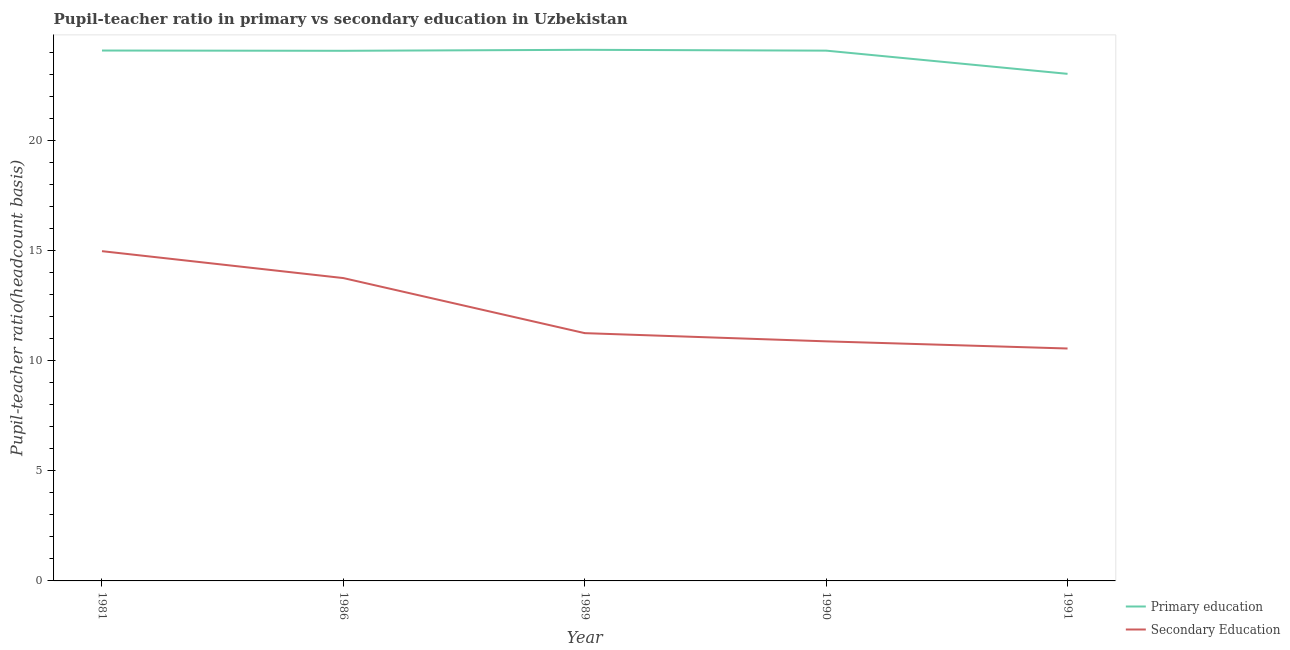How many different coloured lines are there?
Offer a very short reply. 2. What is the pupil teacher ratio on secondary education in 1991?
Provide a short and direct response. 10.56. Across all years, what is the maximum pupil teacher ratio on secondary education?
Offer a terse response. 14.99. Across all years, what is the minimum pupil-teacher ratio in primary education?
Give a very brief answer. 23.05. In which year was the pupil teacher ratio on secondary education minimum?
Provide a succinct answer. 1991. What is the total pupil teacher ratio on secondary education in the graph?
Give a very brief answer. 61.47. What is the difference between the pupil-teacher ratio in primary education in 1981 and that in 1986?
Give a very brief answer. 0.01. What is the difference between the pupil teacher ratio on secondary education in 1981 and the pupil-teacher ratio in primary education in 1990?
Ensure brevity in your answer.  -9.11. What is the average pupil-teacher ratio in primary education per year?
Your response must be concise. 23.9. In the year 1986, what is the difference between the pupil-teacher ratio in primary education and pupil teacher ratio on secondary education?
Offer a very short reply. 10.33. What is the ratio of the pupil teacher ratio on secondary education in 1986 to that in 1989?
Your answer should be compact. 1.22. Is the pupil teacher ratio on secondary education in 1989 less than that in 1990?
Your answer should be very brief. No. What is the difference between the highest and the second highest pupil-teacher ratio in primary education?
Provide a succinct answer. 0.03. What is the difference between the highest and the lowest pupil teacher ratio on secondary education?
Ensure brevity in your answer.  4.42. In how many years, is the pupil teacher ratio on secondary education greater than the average pupil teacher ratio on secondary education taken over all years?
Your answer should be very brief. 2. Does the pupil-teacher ratio in primary education monotonically increase over the years?
Provide a short and direct response. No. Is the pupil teacher ratio on secondary education strictly greater than the pupil-teacher ratio in primary education over the years?
Ensure brevity in your answer.  No. Is the pupil teacher ratio on secondary education strictly less than the pupil-teacher ratio in primary education over the years?
Keep it short and to the point. Yes. How many years are there in the graph?
Offer a very short reply. 5. What is the difference between two consecutive major ticks on the Y-axis?
Make the answer very short. 5. Does the graph contain any zero values?
Keep it short and to the point. No. How many legend labels are there?
Keep it short and to the point. 2. What is the title of the graph?
Give a very brief answer. Pupil-teacher ratio in primary vs secondary education in Uzbekistan. What is the label or title of the Y-axis?
Keep it short and to the point. Pupil-teacher ratio(headcount basis). What is the Pupil-teacher ratio(headcount basis) of Primary education in 1981?
Your answer should be very brief. 24.11. What is the Pupil-teacher ratio(headcount basis) of Secondary Education in 1981?
Your answer should be very brief. 14.99. What is the Pupil-teacher ratio(headcount basis) in Primary education in 1986?
Give a very brief answer. 24.1. What is the Pupil-teacher ratio(headcount basis) of Secondary Education in 1986?
Make the answer very short. 13.76. What is the Pupil-teacher ratio(headcount basis) of Primary education in 1989?
Give a very brief answer. 24.14. What is the Pupil-teacher ratio(headcount basis) in Secondary Education in 1989?
Offer a terse response. 11.26. What is the Pupil-teacher ratio(headcount basis) of Primary education in 1990?
Your response must be concise. 24.1. What is the Pupil-teacher ratio(headcount basis) in Secondary Education in 1990?
Ensure brevity in your answer.  10.89. What is the Pupil-teacher ratio(headcount basis) of Primary education in 1991?
Provide a short and direct response. 23.05. What is the Pupil-teacher ratio(headcount basis) in Secondary Education in 1991?
Your answer should be compact. 10.56. Across all years, what is the maximum Pupil-teacher ratio(headcount basis) of Primary education?
Your answer should be compact. 24.14. Across all years, what is the maximum Pupil-teacher ratio(headcount basis) in Secondary Education?
Make the answer very short. 14.99. Across all years, what is the minimum Pupil-teacher ratio(headcount basis) in Primary education?
Your answer should be very brief. 23.05. Across all years, what is the minimum Pupil-teacher ratio(headcount basis) of Secondary Education?
Your response must be concise. 10.56. What is the total Pupil-teacher ratio(headcount basis) in Primary education in the graph?
Offer a very short reply. 119.49. What is the total Pupil-teacher ratio(headcount basis) of Secondary Education in the graph?
Offer a terse response. 61.47. What is the difference between the Pupil-teacher ratio(headcount basis) in Primary education in 1981 and that in 1986?
Give a very brief answer. 0.01. What is the difference between the Pupil-teacher ratio(headcount basis) of Secondary Education in 1981 and that in 1986?
Your answer should be compact. 1.22. What is the difference between the Pupil-teacher ratio(headcount basis) in Primary education in 1981 and that in 1989?
Provide a short and direct response. -0.03. What is the difference between the Pupil-teacher ratio(headcount basis) in Secondary Education in 1981 and that in 1989?
Provide a short and direct response. 3.73. What is the difference between the Pupil-teacher ratio(headcount basis) in Primary education in 1981 and that in 1990?
Give a very brief answer. 0. What is the difference between the Pupil-teacher ratio(headcount basis) of Secondary Education in 1981 and that in 1990?
Offer a very short reply. 4.1. What is the difference between the Pupil-teacher ratio(headcount basis) of Primary education in 1981 and that in 1991?
Offer a very short reply. 1.06. What is the difference between the Pupil-teacher ratio(headcount basis) in Secondary Education in 1981 and that in 1991?
Give a very brief answer. 4.42. What is the difference between the Pupil-teacher ratio(headcount basis) of Primary education in 1986 and that in 1989?
Ensure brevity in your answer.  -0.04. What is the difference between the Pupil-teacher ratio(headcount basis) in Secondary Education in 1986 and that in 1989?
Offer a very short reply. 2.5. What is the difference between the Pupil-teacher ratio(headcount basis) in Primary education in 1986 and that in 1990?
Give a very brief answer. -0.01. What is the difference between the Pupil-teacher ratio(headcount basis) of Secondary Education in 1986 and that in 1990?
Provide a succinct answer. 2.88. What is the difference between the Pupil-teacher ratio(headcount basis) of Primary education in 1986 and that in 1991?
Give a very brief answer. 1.05. What is the difference between the Pupil-teacher ratio(headcount basis) in Secondary Education in 1986 and that in 1991?
Provide a short and direct response. 3.2. What is the difference between the Pupil-teacher ratio(headcount basis) in Primary education in 1989 and that in 1990?
Make the answer very short. 0.04. What is the difference between the Pupil-teacher ratio(headcount basis) of Secondary Education in 1989 and that in 1990?
Your answer should be compact. 0.37. What is the difference between the Pupil-teacher ratio(headcount basis) of Primary education in 1989 and that in 1991?
Ensure brevity in your answer.  1.09. What is the difference between the Pupil-teacher ratio(headcount basis) in Secondary Education in 1989 and that in 1991?
Make the answer very short. 0.7. What is the difference between the Pupil-teacher ratio(headcount basis) of Primary education in 1990 and that in 1991?
Keep it short and to the point. 1.05. What is the difference between the Pupil-teacher ratio(headcount basis) in Secondary Education in 1990 and that in 1991?
Give a very brief answer. 0.33. What is the difference between the Pupil-teacher ratio(headcount basis) of Primary education in 1981 and the Pupil-teacher ratio(headcount basis) of Secondary Education in 1986?
Offer a terse response. 10.34. What is the difference between the Pupil-teacher ratio(headcount basis) of Primary education in 1981 and the Pupil-teacher ratio(headcount basis) of Secondary Education in 1989?
Your answer should be very brief. 12.85. What is the difference between the Pupil-teacher ratio(headcount basis) of Primary education in 1981 and the Pupil-teacher ratio(headcount basis) of Secondary Education in 1990?
Provide a succinct answer. 13.22. What is the difference between the Pupil-teacher ratio(headcount basis) in Primary education in 1981 and the Pupil-teacher ratio(headcount basis) in Secondary Education in 1991?
Your answer should be very brief. 13.54. What is the difference between the Pupil-teacher ratio(headcount basis) in Primary education in 1986 and the Pupil-teacher ratio(headcount basis) in Secondary Education in 1989?
Provide a succinct answer. 12.83. What is the difference between the Pupil-teacher ratio(headcount basis) of Primary education in 1986 and the Pupil-teacher ratio(headcount basis) of Secondary Education in 1990?
Offer a terse response. 13.21. What is the difference between the Pupil-teacher ratio(headcount basis) in Primary education in 1986 and the Pupil-teacher ratio(headcount basis) in Secondary Education in 1991?
Make the answer very short. 13.53. What is the difference between the Pupil-teacher ratio(headcount basis) in Primary education in 1989 and the Pupil-teacher ratio(headcount basis) in Secondary Education in 1990?
Provide a succinct answer. 13.25. What is the difference between the Pupil-teacher ratio(headcount basis) in Primary education in 1989 and the Pupil-teacher ratio(headcount basis) in Secondary Education in 1991?
Your answer should be very brief. 13.58. What is the difference between the Pupil-teacher ratio(headcount basis) in Primary education in 1990 and the Pupil-teacher ratio(headcount basis) in Secondary Education in 1991?
Ensure brevity in your answer.  13.54. What is the average Pupil-teacher ratio(headcount basis) in Primary education per year?
Provide a short and direct response. 23.9. What is the average Pupil-teacher ratio(headcount basis) in Secondary Education per year?
Provide a short and direct response. 12.29. In the year 1981, what is the difference between the Pupil-teacher ratio(headcount basis) in Primary education and Pupil-teacher ratio(headcount basis) in Secondary Education?
Your answer should be compact. 9.12. In the year 1986, what is the difference between the Pupil-teacher ratio(headcount basis) of Primary education and Pupil-teacher ratio(headcount basis) of Secondary Education?
Ensure brevity in your answer.  10.33. In the year 1989, what is the difference between the Pupil-teacher ratio(headcount basis) in Primary education and Pupil-teacher ratio(headcount basis) in Secondary Education?
Provide a succinct answer. 12.88. In the year 1990, what is the difference between the Pupil-teacher ratio(headcount basis) of Primary education and Pupil-teacher ratio(headcount basis) of Secondary Education?
Provide a succinct answer. 13.21. In the year 1991, what is the difference between the Pupil-teacher ratio(headcount basis) of Primary education and Pupil-teacher ratio(headcount basis) of Secondary Education?
Give a very brief answer. 12.48. What is the ratio of the Pupil-teacher ratio(headcount basis) in Secondary Education in 1981 to that in 1986?
Your response must be concise. 1.09. What is the ratio of the Pupil-teacher ratio(headcount basis) in Secondary Education in 1981 to that in 1989?
Provide a short and direct response. 1.33. What is the ratio of the Pupil-teacher ratio(headcount basis) of Primary education in 1981 to that in 1990?
Offer a very short reply. 1. What is the ratio of the Pupil-teacher ratio(headcount basis) of Secondary Education in 1981 to that in 1990?
Make the answer very short. 1.38. What is the ratio of the Pupil-teacher ratio(headcount basis) in Primary education in 1981 to that in 1991?
Make the answer very short. 1.05. What is the ratio of the Pupil-teacher ratio(headcount basis) in Secondary Education in 1981 to that in 1991?
Offer a very short reply. 1.42. What is the ratio of the Pupil-teacher ratio(headcount basis) of Primary education in 1986 to that in 1989?
Give a very brief answer. 1. What is the ratio of the Pupil-teacher ratio(headcount basis) of Secondary Education in 1986 to that in 1989?
Your response must be concise. 1.22. What is the ratio of the Pupil-teacher ratio(headcount basis) of Primary education in 1986 to that in 1990?
Give a very brief answer. 1. What is the ratio of the Pupil-teacher ratio(headcount basis) of Secondary Education in 1986 to that in 1990?
Keep it short and to the point. 1.26. What is the ratio of the Pupil-teacher ratio(headcount basis) in Primary education in 1986 to that in 1991?
Provide a short and direct response. 1.05. What is the ratio of the Pupil-teacher ratio(headcount basis) in Secondary Education in 1986 to that in 1991?
Provide a succinct answer. 1.3. What is the ratio of the Pupil-teacher ratio(headcount basis) in Secondary Education in 1989 to that in 1990?
Offer a terse response. 1.03. What is the ratio of the Pupil-teacher ratio(headcount basis) of Primary education in 1989 to that in 1991?
Ensure brevity in your answer.  1.05. What is the ratio of the Pupil-teacher ratio(headcount basis) of Secondary Education in 1989 to that in 1991?
Provide a short and direct response. 1.07. What is the ratio of the Pupil-teacher ratio(headcount basis) in Primary education in 1990 to that in 1991?
Keep it short and to the point. 1.05. What is the ratio of the Pupil-teacher ratio(headcount basis) of Secondary Education in 1990 to that in 1991?
Your answer should be compact. 1.03. What is the difference between the highest and the second highest Pupil-teacher ratio(headcount basis) in Primary education?
Provide a succinct answer. 0.03. What is the difference between the highest and the second highest Pupil-teacher ratio(headcount basis) in Secondary Education?
Keep it short and to the point. 1.22. What is the difference between the highest and the lowest Pupil-teacher ratio(headcount basis) in Primary education?
Make the answer very short. 1.09. What is the difference between the highest and the lowest Pupil-teacher ratio(headcount basis) in Secondary Education?
Give a very brief answer. 4.42. 